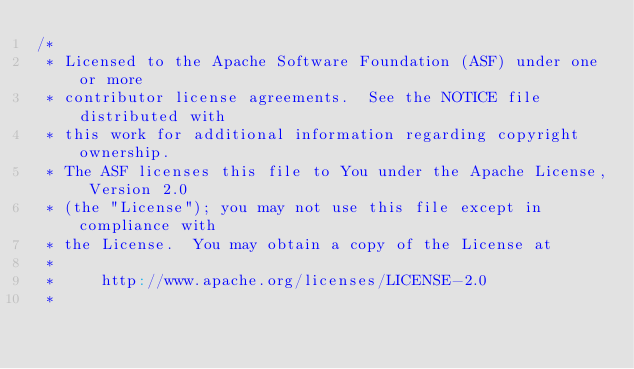Convert code to text. <code><loc_0><loc_0><loc_500><loc_500><_Scala_>/*
 * Licensed to the Apache Software Foundation (ASF) under one or more
 * contributor license agreements.  See the NOTICE file distributed with
 * this work for additional information regarding copyright ownership.
 * The ASF licenses this file to You under the Apache License, Version 2.0
 * (the "License"); you may not use this file except in compliance with
 * the License.  You may obtain a copy of the License at
 *
 *     http://www.apache.org/licenses/LICENSE-2.0
 *</code> 